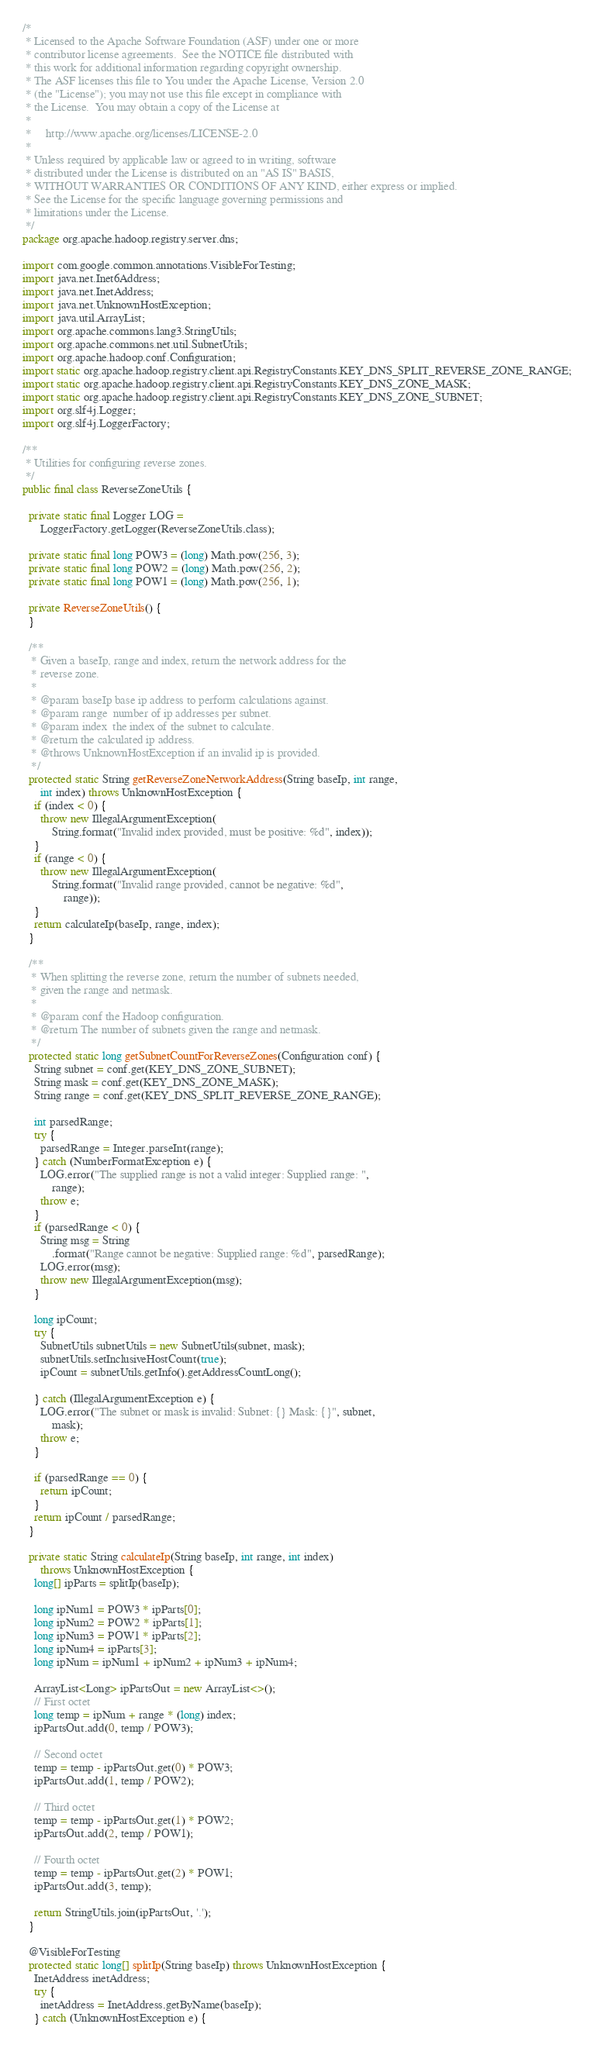<code> <loc_0><loc_0><loc_500><loc_500><_Java_>/*
 * Licensed to the Apache Software Foundation (ASF) under one or more
 * contributor license agreements.  See the NOTICE file distributed with
 * this work for additional information regarding copyright ownership.
 * The ASF licenses this file to You under the Apache License, Version 2.0
 * (the "License"); you may not use this file except in compliance with
 * the License.  You may obtain a copy of the License at
 *
 *     http://www.apache.org/licenses/LICENSE-2.0
 *
 * Unless required by applicable law or agreed to in writing, software
 * distributed under the License is distributed on an "AS IS" BASIS,
 * WITHOUT WARRANTIES OR CONDITIONS OF ANY KIND, either express or implied.
 * See the License for the specific language governing permissions and
 * limitations under the License.
 */
package org.apache.hadoop.registry.server.dns;

import com.google.common.annotations.VisibleForTesting;
import java.net.Inet6Address;
import java.net.InetAddress;
import java.net.UnknownHostException;
import java.util.ArrayList;
import org.apache.commons.lang3.StringUtils;
import org.apache.commons.net.util.SubnetUtils;
import org.apache.hadoop.conf.Configuration;
import static org.apache.hadoop.registry.client.api.RegistryConstants.KEY_DNS_SPLIT_REVERSE_ZONE_RANGE;
import static org.apache.hadoop.registry.client.api.RegistryConstants.KEY_DNS_ZONE_MASK;
import static org.apache.hadoop.registry.client.api.RegistryConstants.KEY_DNS_ZONE_SUBNET;
import org.slf4j.Logger;
import org.slf4j.LoggerFactory;

/**
 * Utilities for configuring reverse zones.
 */
public final class ReverseZoneUtils {

  private static final Logger LOG =
      LoggerFactory.getLogger(ReverseZoneUtils.class);

  private static final long POW3 = (long) Math.pow(256, 3);
  private static final long POW2 = (long) Math.pow(256, 2);
  private static final long POW1 = (long) Math.pow(256, 1);

  private ReverseZoneUtils() {
  }

  /**
   * Given a baseIp, range and index, return the network address for the
   * reverse zone.
   *
   * @param baseIp base ip address to perform calculations against.
   * @param range  number of ip addresses per subnet.
   * @param index  the index of the subnet to calculate.
   * @return the calculated ip address.
   * @throws UnknownHostException if an invalid ip is provided.
   */
  protected static String getReverseZoneNetworkAddress(String baseIp, int range,
      int index) throws UnknownHostException {
    if (index < 0) {
      throw new IllegalArgumentException(
          String.format("Invalid index provided, must be positive: %d", index));
    }
    if (range < 0) {
      throw new IllegalArgumentException(
          String.format("Invalid range provided, cannot be negative: %d",
              range));
    }
    return calculateIp(baseIp, range, index);
  }

  /**
   * When splitting the reverse zone, return the number of subnets needed,
   * given the range and netmask.
   *
   * @param conf the Hadoop configuration.
   * @return The number of subnets given the range and netmask.
   */
  protected static long getSubnetCountForReverseZones(Configuration conf) {
    String subnet = conf.get(KEY_DNS_ZONE_SUBNET);
    String mask = conf.get(KEY_DNS_ZONE_MASK);
    String range = conf.get(KEY_DNS_SPLIT_REVERSE_ZONE_RANGE);

    int parsedRange;
    try {
      parsedRange = Integer.parseInt(range);
    } catch (NumberFormatException e) {
      LOG.error("The supplied range is not a valid integer: Supplied range: ",
          range);
      throw e;
    }
    if (parsedRange < 0) {
      String msg = String
          .format("Range cannot be negative: Supplied range: %d", parsedRange);
      LOG.error(msg);
      throw new IllegalArgumentException(msg);
    }

    long ipCount;
    try {
      SubnetUtils subnetUtils = new SubnetUtils(subnet, mask);
      subnetUtils.setInclusiveHostCount(true);
      ipCount = subnetUtils.getInfo().getAddressCountLong();

    } catch (IllegalArgumentException e) {
      LOG.error("The subnet or mask is invalid: Subnet: {} Mask: {}", subnet,
          mask);
      throw e;
    }

    if (parsedRange == 0) {
      return ipCount;
    }
    return ipCount / parsedRange;
  }

  private static String calculateIp(String baseIp, int range, int index)
      throws UnknownHostException {
    long[] ipParts = splitIp(baseIp);

    long ipNum1 = POW3 * ipParts[0];
    long ipNum2 = POW2 * ipParts[1];
    long ipNum3 = POW1 * ipParts[2];
    long ipNum4 = ipParts[3];
    long ipNum = ipNum1 + ipNum2 + ipNum3 + ipNum4;

    ArrayList<Long> ipPartsOut = new ArrayList<>();
    // First octet
    long temp = ipNum + range * (long) index;
    ipPartsOut.add(0, temp / POW3);

    // Second octet
    temp = temp - ipPartsOut.get(0) * POW3;
    ipPartsOut.add(1, temp / POW2);

    // Third octet
    temp = temp - ipPartsOut.get(1) * POW2;
    ipPartsOut.add(2, temp / POW1);

    // Fourth octet
    temp = temp - ipPartsOut.get(2) * POW1;
    ipPartsOut.add(3, temp);

    return StringUtils.join(ipPartsOut, '.');
  }

  @VisibleForTesting
  protected static long[] splitIp(String baseIp) throws UnknownHostException {
    InetAddress inetAddress;
    try {
      inetAddress = InetAddress.getByName(baseIp);
    } catch (UnknownHostException e) {</code> 